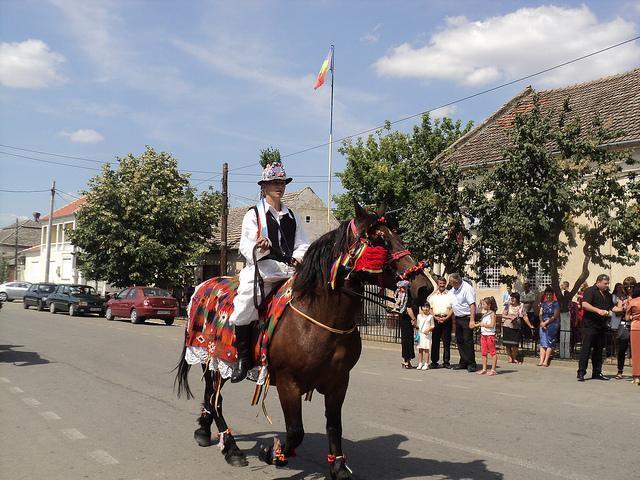How many buckles are holding the harness?
Give a very brief answer. 2. How many horses are there?
Give a very brief answer. 1. How many people are there?
Give a very brief answer. 2. How many of the people sitting have a laptop on there lap?
Give a very brief answer. 0. 